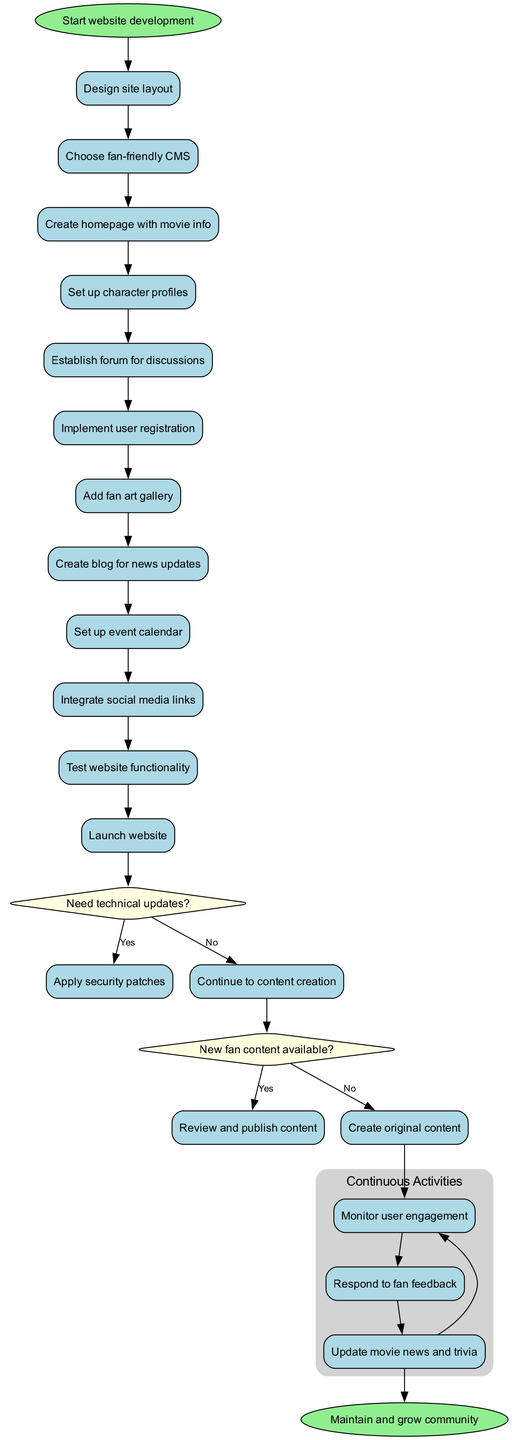What is the first node in the diagram? The first node in the diagram is labeled 'Start website development', indicating the initiation of the process.
Answer: Start website development How many activities are listed in the diagram? There are a total of 11 activities outlined in the diagram that the user must carry out.
Answer: 11 What is the last activity before the decision node regarding technical updates? The last activity before this decision node is 'Test website functionality', which is a crucial step before considering updates.
Answer: Test website functionality If the answer to the question "Need technical updates?" is no, which activity follows? If the answer is no, the next activity would be 'Continue to content creation', indicating a shift back to creating content rather than updating the site.
Answer: Continue to content creation What continuous activities are monitored in the loop? The continuous activities monitored in the loop include 'Monitor user engagement', 'Respond to fan feedback', and 'Update movie news and trivia', which are essential for ongoing community interaction.
Answer: Monitor user engagement, Respond to fan feedback, Update movie news and trivia What color represents the decision nodes on the diagram? The decision nodes are colored light yellow, distinguishing them from other types of nodes in the diagram.
Answer: Light yellow What happens if new fan content is available? If new fan content is available, the next action taken is to 'Review and publish content', allowing for fresh community engagement.
Answer: Review and publish content How does the diagram depict the relationship between the last loop activity and the final node? The diagram shows an edge connecting the last loop activity to the final node 'Maintain and grow community', indicating that ongoing efforts lead to community maintenance.
Answer: Maintain and grow community 